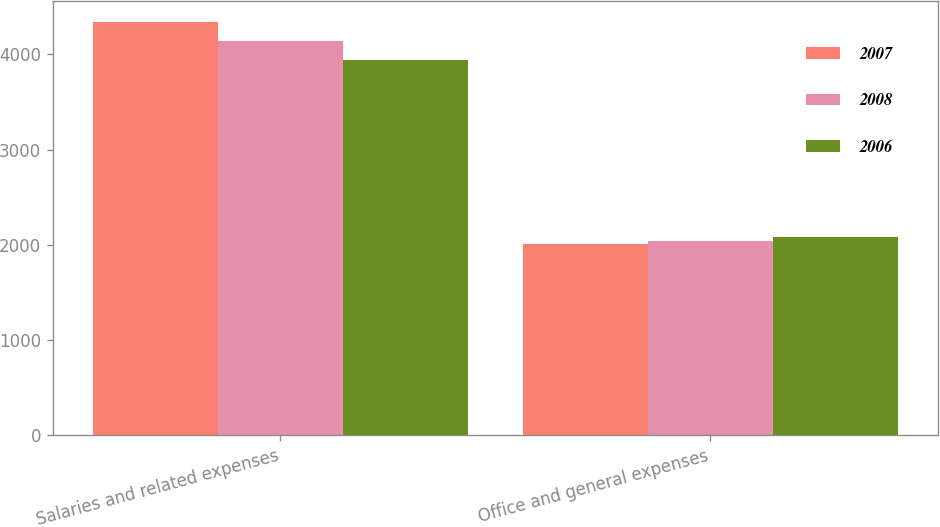<chart> <loc_0><loc_0><loc_500><loc_500><stacked_bar_chart><ecel><fcel>Salaries and related expenses<fcel>Office and general expenses<nl><fcel>2007<fcel>4342.6<fcel>2013.3<nl><fcel>2008<fcel>4139.2<fcel>2044.8<nl><fcel>2006<fcel>3944.1<fcel>2079<nl></chart> 